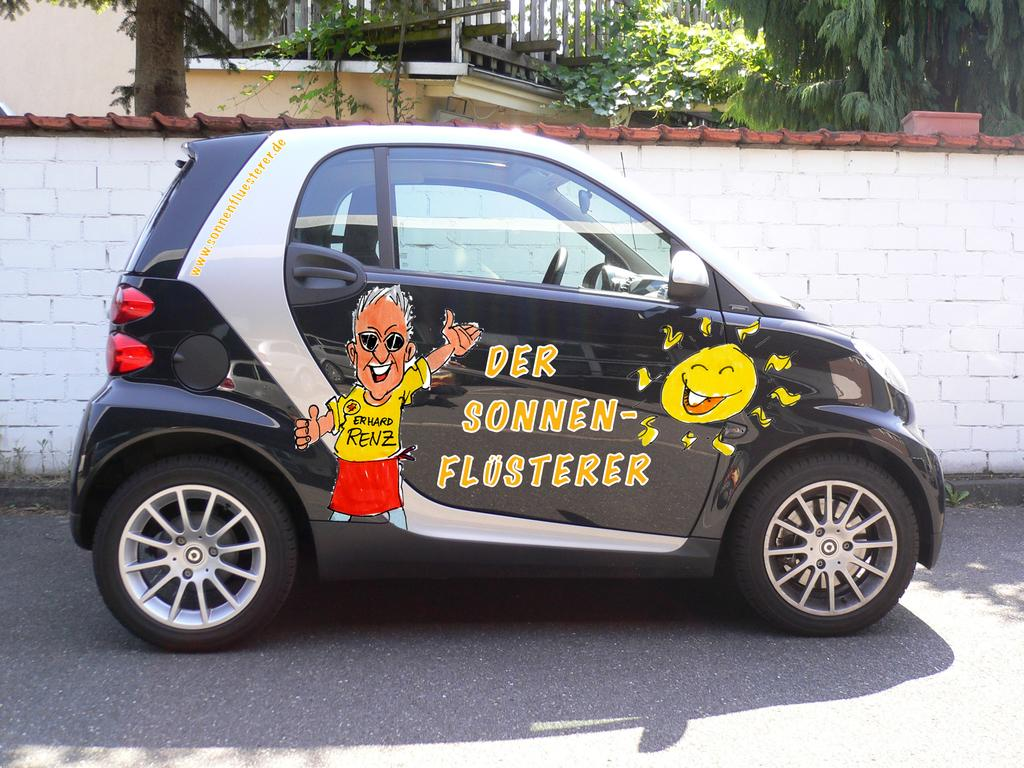What type of car is in the image? There is a black car in the image. What distinguishing feature does the car have? The car has cartoon pictures on it. What can be seen behind the car in the image? There is a brick wall in the image. What color is the brick wall? The brick wall is white. What type of vegetation is visible in the image? There are trees visible in the back side of the image. What sense is being stimulated by the art on the car? The image does not provide information about any art on the car stimulating a sense. 